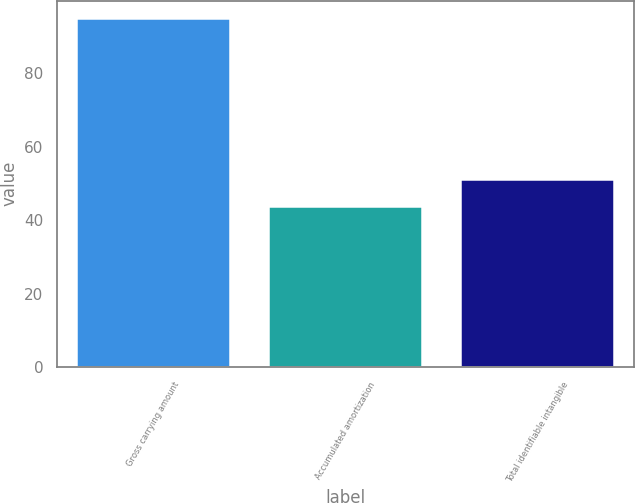Convert chart. <chart><loc_0><loc_0><loc_500><loc_500><bar_chart><fcel>Gross carrying amount<fcel>Accumulated amortization<fcel>Total identifiable intangible<nl><fcel>95.1<fcel>43.9<fcel>51.2<nl></chart> 